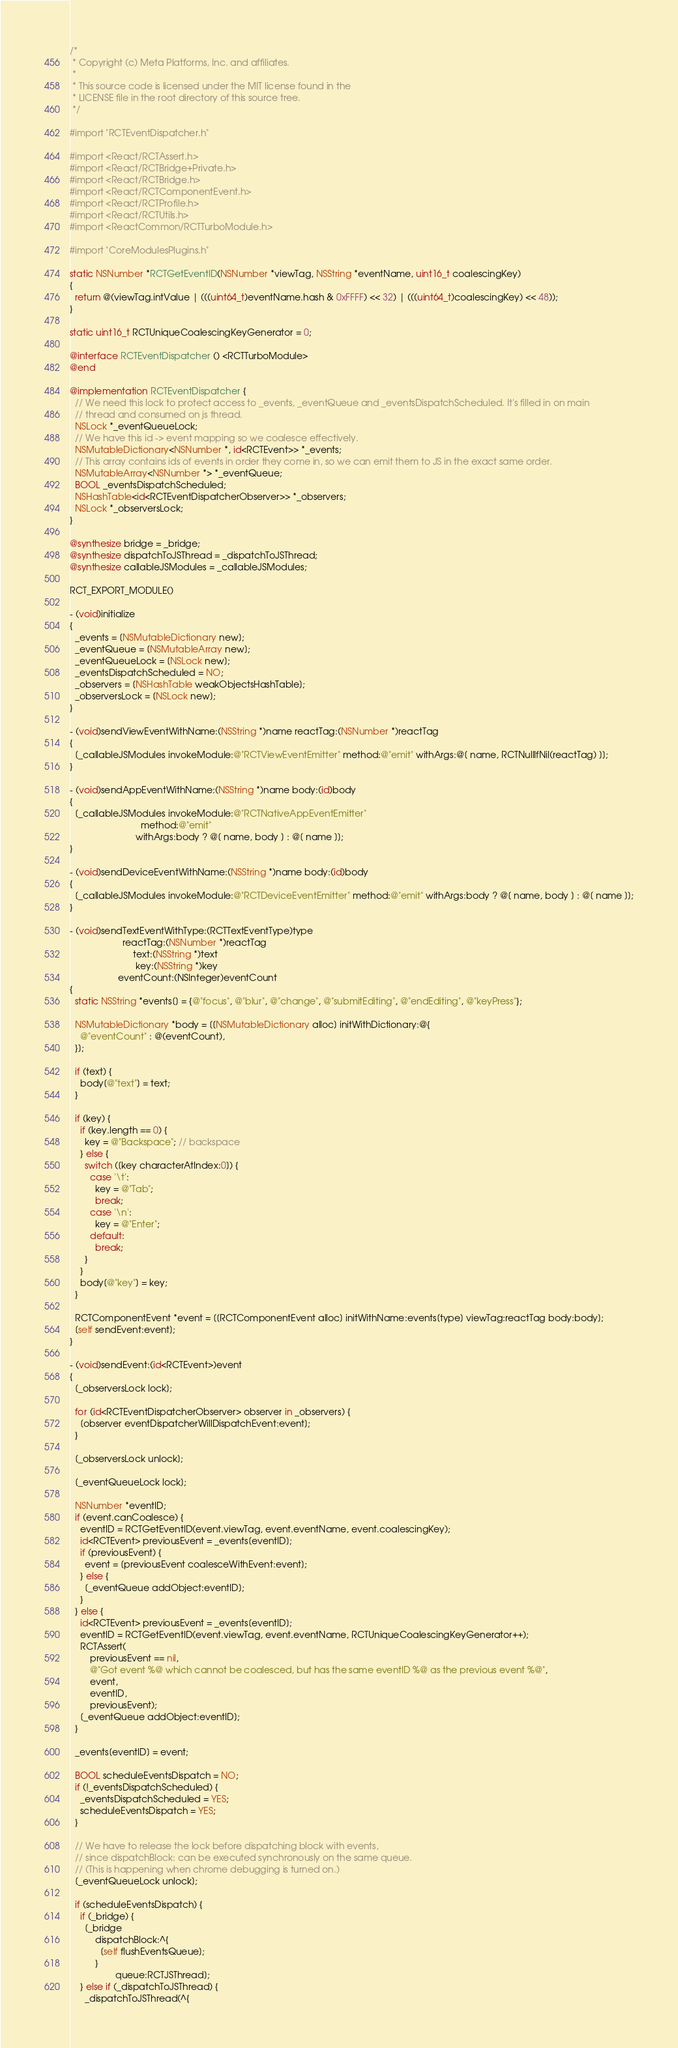Convert code to text. <code><loc_0><loc_0><loc_500><loc_500><_ObjectiveC_>/*
 * Copyright (c) Meta Platforms, Inc. and affiliates.
 *
 * This source code is licensed under the MIT license found in the
 * LICENSE file in the root directory of this source tree.
 */

#import "RCTEventDispatcher.h"

#import <React/RCTAssert.h>
#import <React/RCTBridge+Private.h>
#import <React/RCTBridge.h>
#import <React/RCTComponentEvent.h>
#import <React/RCTProfile.h>
#import <React/RCTUtils.h>
#import <ReactCommon/RCTTurboModule.h>

#import "CoreModulesPlugins.h"

static NSNumber *RCTGetEventID(NSNumber *viewTag, NSString *eventName, uint16_t coalescingKey)
{
  return @(viewTag.intValue | (((uint64_t)eventName.hash & 0xFFFF) << 32) | (((uint64_t)coalescingKey) << 48));
}

static uint16_t RCTUniqueCoalescingKeyGenerator = 0;

@interface RCTEventDispatcher () <RCTTurboModule>
@end

@implementation RCTEventDispatcher {
  // We need this lock to protect access to _events, _eventQueue and _eventsDispatchScheduled. It's filled in on main
  // thread and consumed on js thread.
  NSLock *_eventQueueLock;
  // We have this id -> event mapping so we coalesce effectively.
  NSMutableDictionary<NSNumber *, id<RCTEvent>> *_events;
  // This array contains ids of events in order they come in, so we can emit them to JS in the exact same order.
  NSMutableArray<NSNumber *> *_eventQueue;
  BOOL _eventsDispatchScheduled;
  NSHashTable<id<RCTEventDispatcherObserver>> *_observers;
  NSLock *_observersLock;
}

@synthesize bridge = _bridge;
@synthesize dispatchToJSThread = _dispatchToJSThread;
@synthesize callableJSModules = _callableJSModules;

RCT_EXPORT_MODULE()

- (void)initialize
{
  _events = [NSMutableDictionary new];
  _eventQueue = [NSMutableArray new];
  _eventQueueLock = [NSLock new];
  _eventsDispatchScheduled = NO;
  _observers = [NSHashTable weakObjectsHashTable];
  _observersLock = [NSLock new];
}

- (void)sendViewEventWithName:(NSString *)name reactTag:(NSNumber *)reactTag
{
  [_callableJSModules invokeModule:@"RCTViewEventEmitter" method:@"emit" withArgs:@[ name, RCTNullIfNil(reactTag) ]];
}

- (void)sendAppEventWithName:(NSString *)name body:(id)body
{
  [_callableJSModules invokeModule:@"RCTNativeAppEventEmitter"
                            method:@"emit"
                          withArgs:body ? @[ name, body ] : @[ name ]];
}

- (void)sendDeviceEventWithName:(NSString *)name body:(id)body
{
  [_callableJSModules invokeModule:@"RCTDeviceEventEmitter" method:@"emit" withArgs:body ? @[ name, body ] : @[ name ]];
}

- (void)sendTextEventWithType:(RCTTextEventType)type
                     reactTag:(NSNumber *)reactTag
                         text:(NSString *)text
                          key:(NSString *)key
                   eventCount:(NSInteger)eventCount
{
  static NSString *events[] = {@"focus", @"blur", @"change", @"submitEditing", @"endEditing", @"keyPress"};

  NSMutableDictionary *body = [[NSMutableDictionary alloc] initWithDictionary:@{
    @"eventCount" : @(eventCount),
  }];

  if (text) {
    body[@"text"] = text;
  }

  if (key) {
    if (key.length == 0) {
      key = @"Backspace"; // backspace
    } else {
      switch ([key characterAtIndex:0]) {
        case '\t':
          key = @"Tab";
          break;
        case '\n':
          key = @"Enter";
        default:
          break;
      }
    }
    body[@"key"] = key;
  }

  RCTComponentEvent *event = [[RCTComponentEvent alloc] initWithName:events[type] viewTag:reactTag body:body];
  [self sendEvent:event];
}

- (void)sendEvent:(id<RCTEvent>)event
{
  [_observersLock lock];

  for (id<RCTEventDispatcherObserver> observer in _observers) {
    [observer eventDispatcherWillDispatchEvent:event];
  }

  [_observersLock unlock];

  [_eventQueueLock lock];

  NSNumber *eventID;
  if (event.canCoalesce) {
    eventID = RCTGetEventID(event.viewTag, event.eventName, event.coalescingKey);
    id<RCTEvent> previousEvent = _events[eventID];
    if (previousEvent) {
      event = [previousEvent coalesceWithEvent:event];
    } else {
      [_eventQueue addObject:eventID];
    }
  } else {
    id<RCTEvent> previousEvent = _events[eventID];
    eventID = RCTGetEventID(event.viewTag, event.eventName, RCTUniqueCoalescingKeyGenerator++);
    RCTAssert(
        previousEvent == nil,
        @"Got event %@ which cannot be coalesced, but has the same eventID %@ as the previous event %@",
        event,
        eventID,
        previousEvent);
    [_eventQueue addObject:eventID];
  }

  _events[eventID] = event;

  BOOL scheduleEventsDispatch = NO;
  if (!_eventsDispatchScheduled) {
    _eventsDispatchScheduled = YES;
    scheduleEventsDispatch = YES;
  }

  // We have to release the lock before dispatching block with events,
  // since dispatchBlock: can be executed synchronously on the same queue.
  // (This is happening when chrome debugging is turned on.)
  [_eventQueueLock unlock];

  if (scheduleEventsDispatch) {
    if (_bridge) {
      [_bridge
          dispatchBlock:^{
            [self flushEventsQueue];
          }
                  queue:RCTJSThread];
    } else if (_dispatchToJSThread) {
      _dispatchToJSThread(^{</code> 